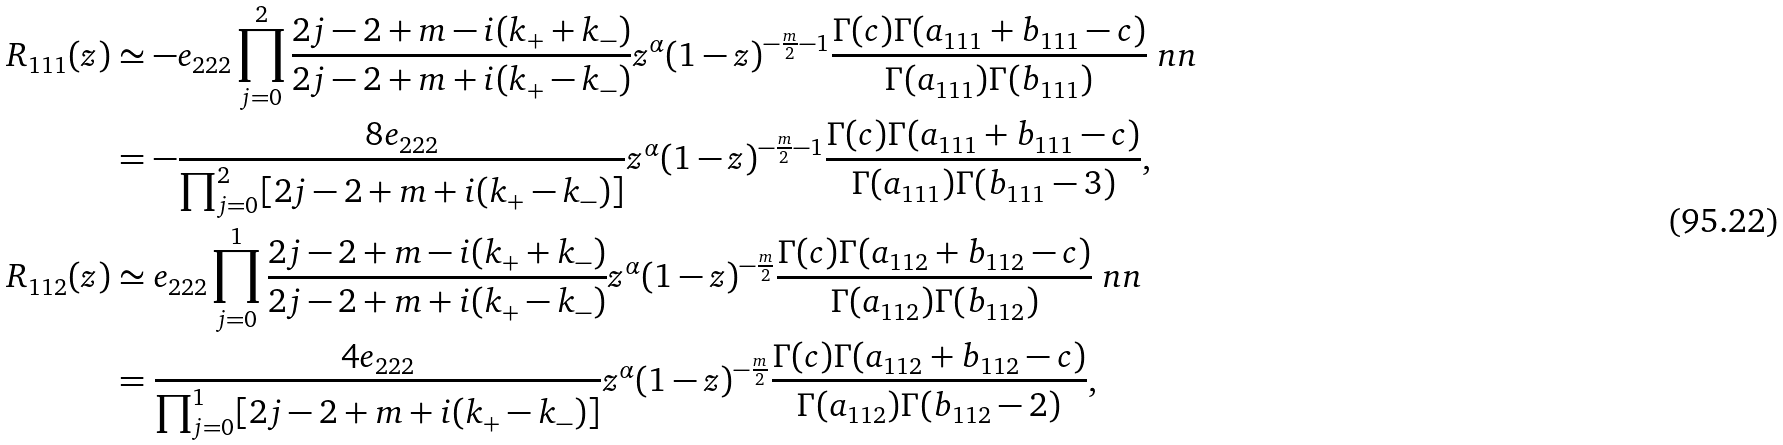Convert formula to latex. <formula><loc_0><loc_0><loc_500><loc_500>R _ { 1 1 1 } ( z ) & \simeq - e _ { 2 2 2 } \prod _ { j = 0 } ^ { 2 } \frac { 2 j - 2 + m - i ( k _ { + } + k _ { - } ) } { 2 j - 2 + m + i ( k _ { + } - k _ { - } ) } z ^ { \alpha } ( 1 - z ) ^ { - \frac { m } { 2 } - 1 } \frac { \Gamma ( c ) \Gamma ( a _ { 1 1 1 } + b _ { 1 1 1 } - c ) } { \Gamma ( a _ { 1 1 1 } ) \Gamma ( b _ { 1 1 1 } ) } \ n n \\ & = - \frac { 8 e _ { 2 2 2 } } { \prod _ { j = 0 } ^ { 2 } [ 2 j - 2 + m + i ( k _ { + } - k _ { - } ) ] } z ^ { \alpha } ( 1 - z ) ^ { - \frac { m } { 2 } - 1 } \frac { \Gamma ( c ) \Gamma ( a _ { 1 1 1 } + b _ { 1 1 1 } - c ) } { \Gamma ( a _ { 1 1 1 } ) \Gamma ( b _ { 1 1 1 } - 3 ) } , \\ R _ { 1 1 2 } ( z ) & \simeq e _ { 2 2 2 } \prod _ { j = 0 } ^ { 1 } \frac { 2 j - 2 + m - i ( k _ { + } + k _ { - } ) } { 2 j - 2 + m + i ( k _ { + } - k _ { - } ) } z ^ { \alpha } ( 1 - z ) ^ { - \frac { m } { 2 } } \frac { \Gamma ( c ) \Gamma ( a _ { 1 1 2 } + b _ { 1 1 2 } - c ) } { \Gamma ( a _ { 1 1 2 } ) \Gamma ( b _ { 1 1 2 } ) } \ n n \\ & = \frac { 4 e _ { 2 2 2 } } { \prod _ { j = 0 } ^ { 1 } [ 2 j - 2 + m + i ( k _ { + } - k _ { - } ) ] } z ^ { \alpha } ( 1 - z ) ^ { - \frac { m } { 2 } } \frac { \Gamma ( c ) \Gamma ( a _ { 1 1 2 } + b _ { 1 1 2 } - c ) } { \Gamma ( a _ { 1 1 2 } ) \Gamma ( b _ { 1 1 2 } - 2 ) } ,</formula> 